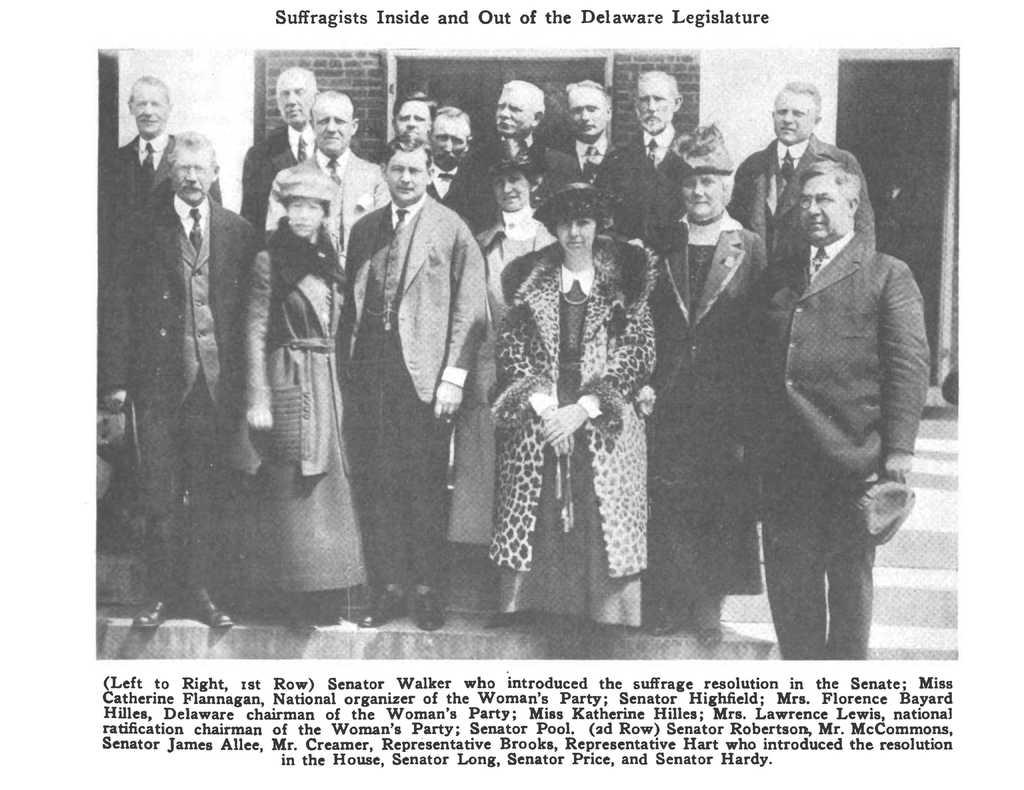What is the main subject of the image? There is an article in the image. What is featured within the article? There is a picture in the article. What can be seen in the picture? The picture contains a group of people. Where are the people located in the picture? The group of people are standing on stairs. What is visible in the background of the picture? There is a brick wall in the background of the picture. What type of sponge is being used by the person sitting on the throne in the image? There is no sponge or throne present in the image. 